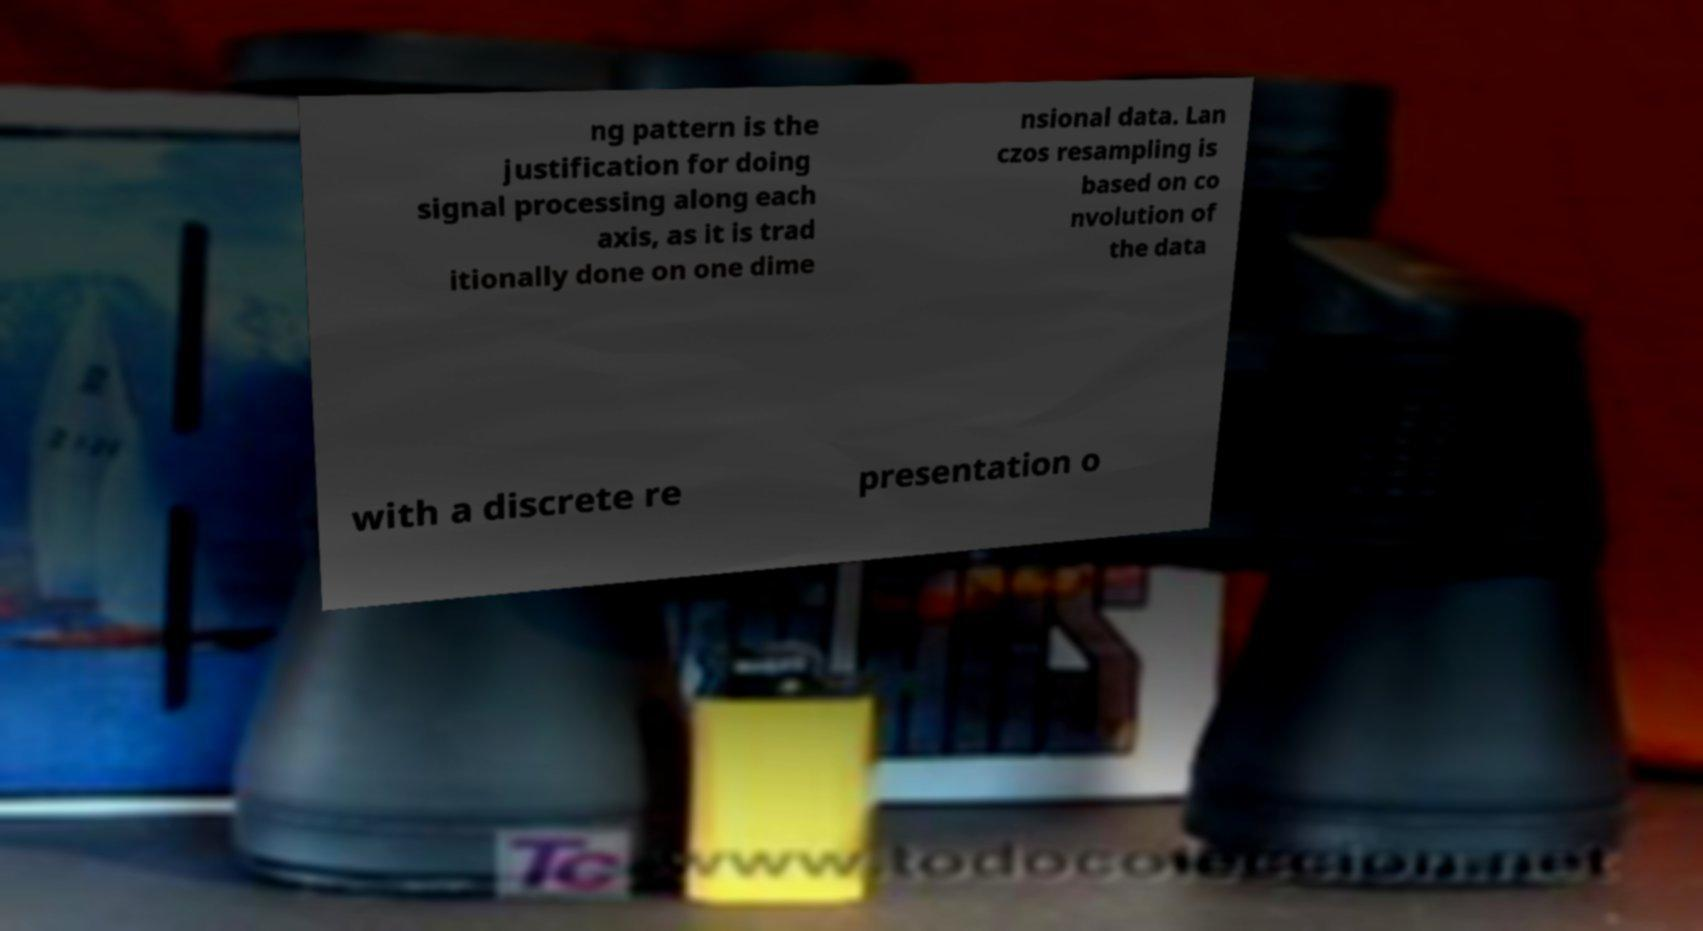Could you assist in decoding the text presented in this image and type it out clearly? ng pattern is the justification for doing signal processing along each axis, as it is trad itionally done on one dime nsional data. Lan czos resampling is based on co nvolution of the data with a discrete re presentation o 